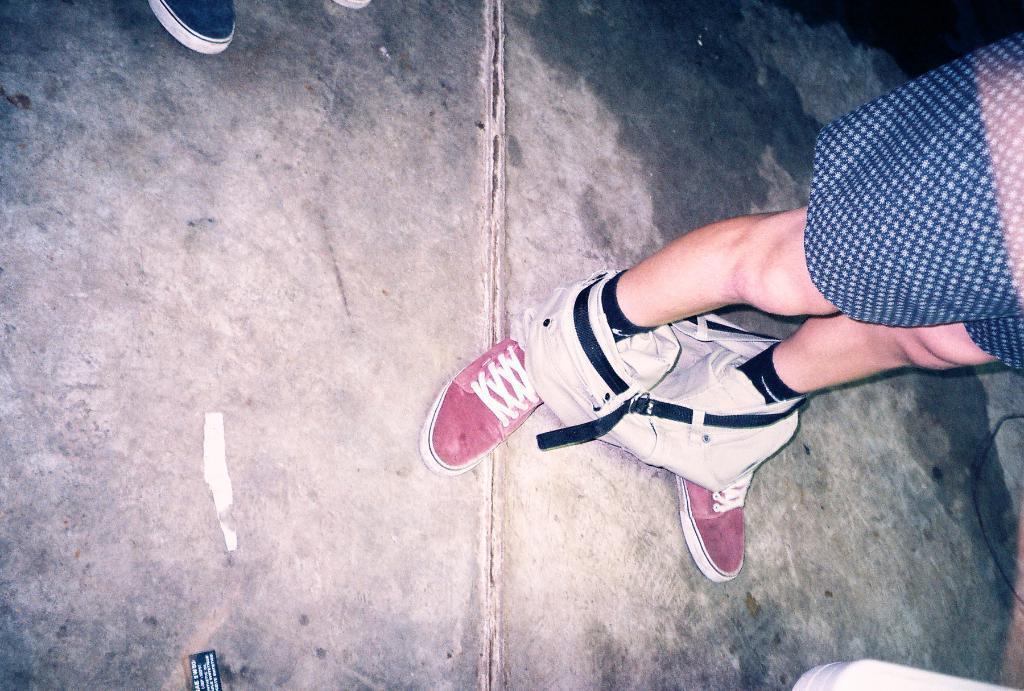Could you give a brief overview of what you see in this image? In the picture we can see a person standing on the path, he is with red color shoes, removed pant with belt to it and beside the person we can see a part of the shoe. 